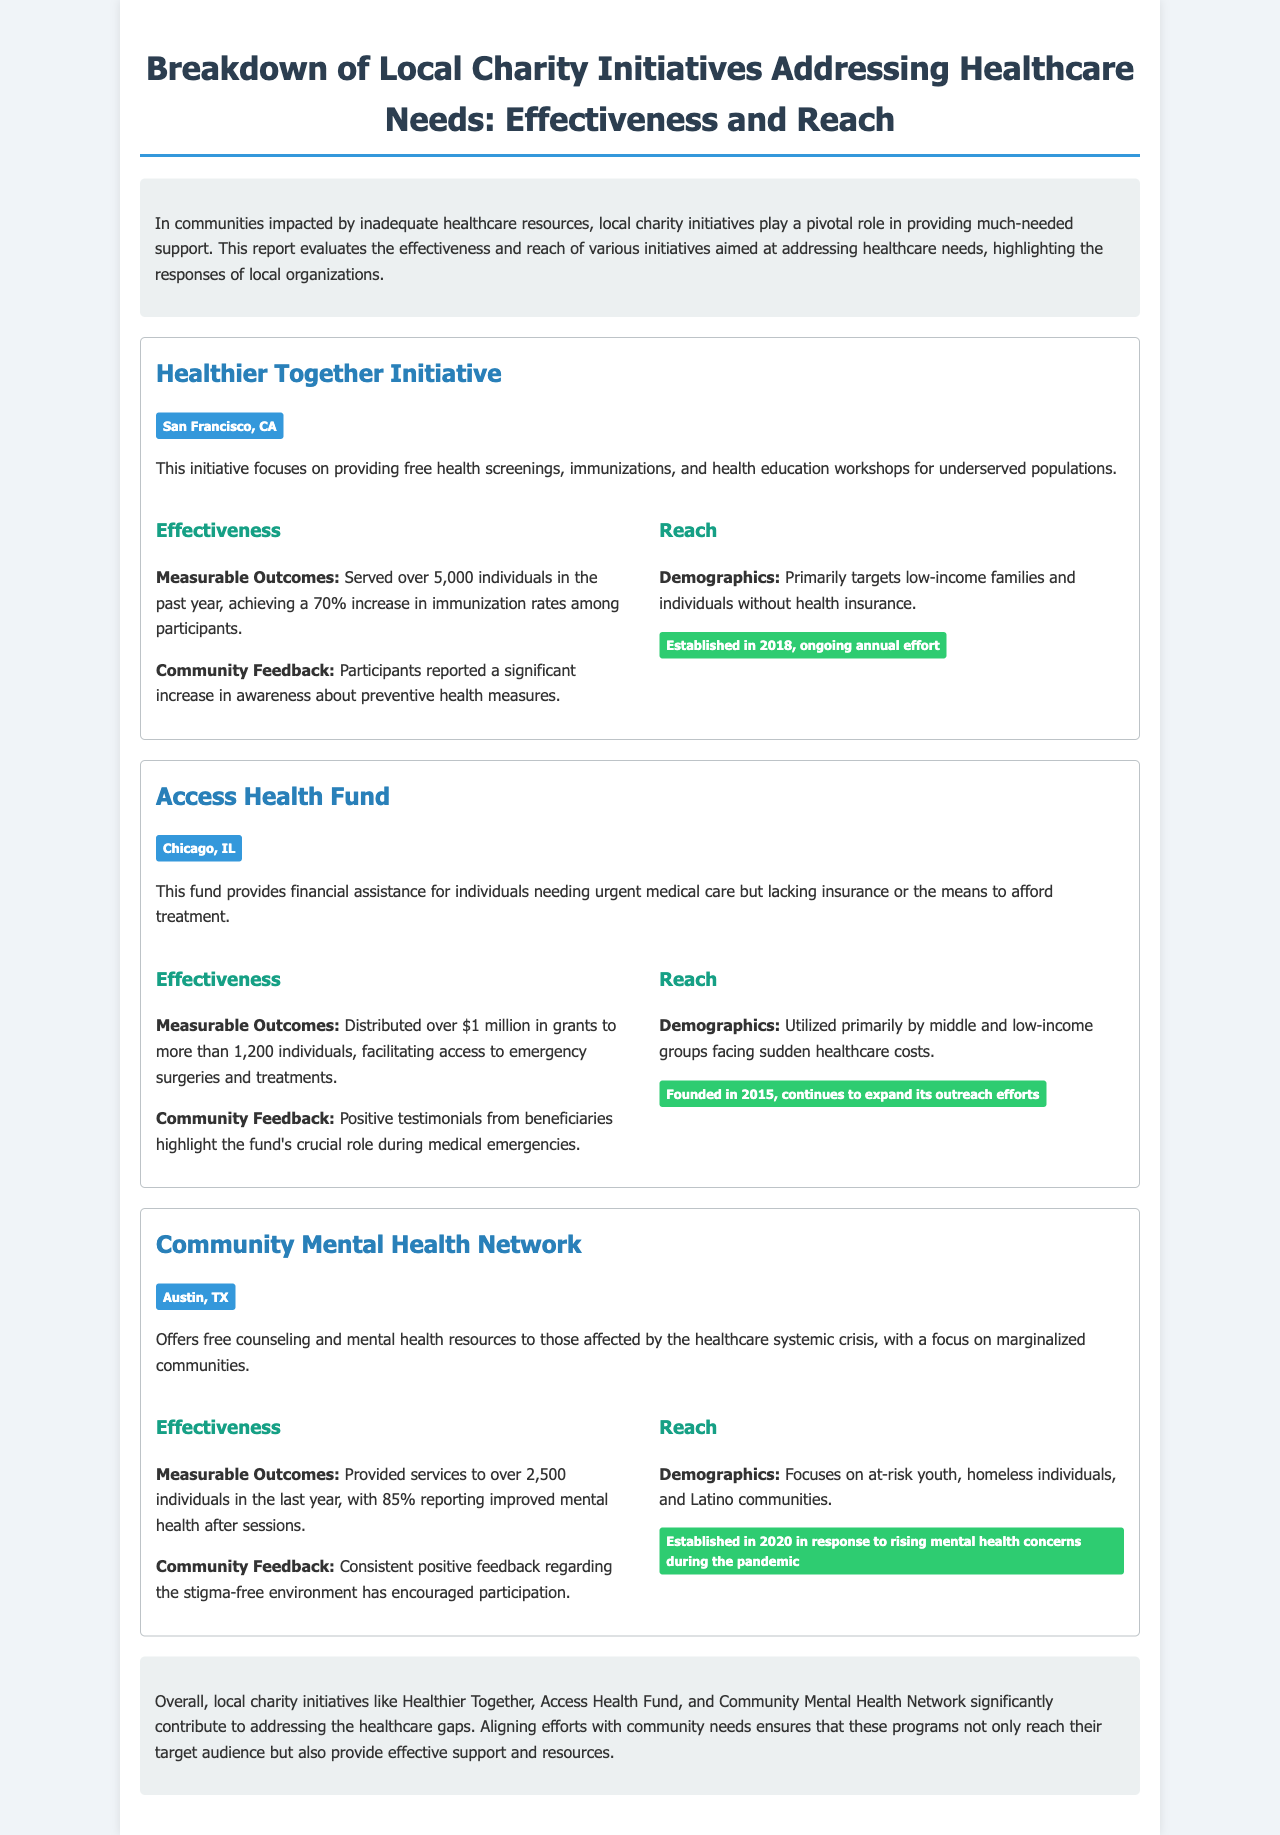what is the location of the Healthier Together Initiative? The location is specifically mentioned under the initiative title.
Answer: San Francisco, CA how many individuals did the Access Health Fund serve? The number served can be found in the effectiveness section of the Access Health Fund initiative.
Answer: 1,200 individuals what year was the Community Mental Health Network established? The establishment year is noted in the duration section of the initiative.
Answer: 2020 what percentage of participants reported improved mental health after counseling? The percentage is stated in the effectiveness section of the Community Mental Health Network initiative.
Answer: 85% how much funding did the Access Health Fund distribute? The amount funded is specified in the measurable outcomes of the Access Health Fund initiative.
Answer: over $1 million what type of community does the Healthier Together Initiative primarily target? The demographic information is outlined in the reach section of the initiative.
Answer: low-income families and individuals without health insurance what initiative has been established since 2018? The initiative with this establishment year is found in the document under the relevant section.
Answer: Healthier Together Initiative what is a measurable outcome for the Healthier Together Initiative? Measurable outcomes are highlighted in the effectiveness part of each initiative.
Answer: 70% increase in immunization rates among participants 